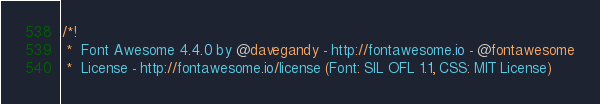<code> <loc_0><loc_0><loc_500><loc_500><_CSS_>/*!
 *  Font Awesome 4.4.0 by @davegandy - http://fontawesome.io - @fontawesome
 *  License - http://fontawesome.io/license (Font: SIL OFL 1.1, CSS: MIT License)</code> 